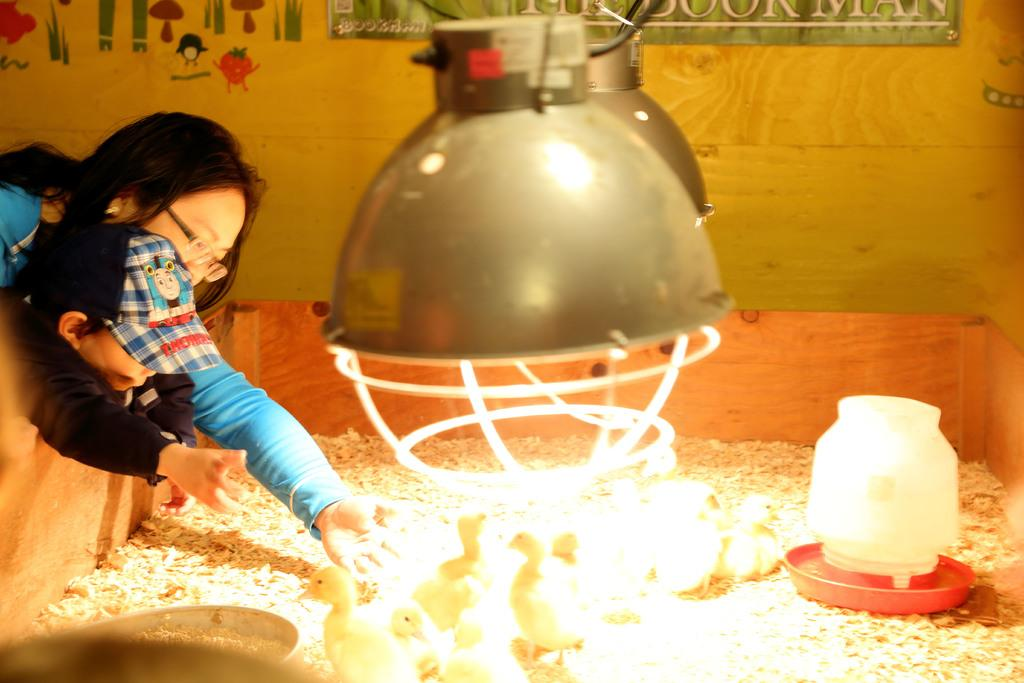What animals are in the box in the image? There are chickens in the box in the image. What objects can be seen in the image besides the chickens? There are bowls visible in the image. Who else is present in the image? There is a woman and a boy in the image. What are the woman and the boy doing in the image? The woman and the boy are trying to catch a chicken. What type of structure is visible in the background of the image? There is a wooden wall in the image. What can be seen hanging in the image? There are lights hanging in the image. Can you tell me how many squirrels are trying to climb the wooden wall in the image? There are no squirrels visible in the image; it only features chickens, bowls, a woman, a boy, a wooden wall, and lights. 